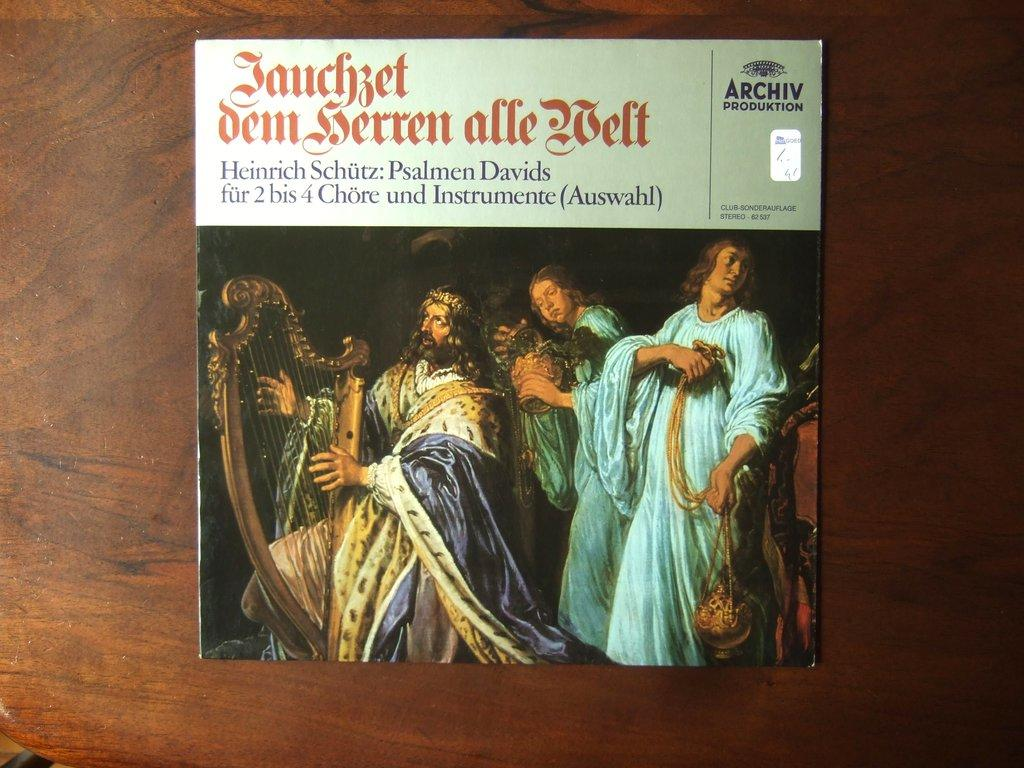Provide a one-sentence caption for the provided image. Old time Victorian band including a harp and drum plus incense. 